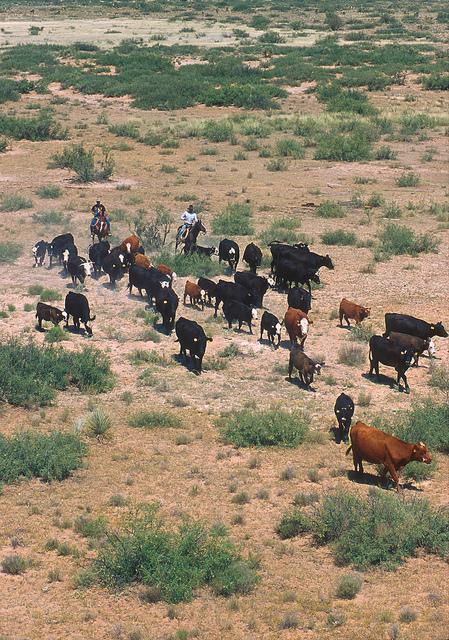How many cows can be seen?
Give a very brief answer. 2. 